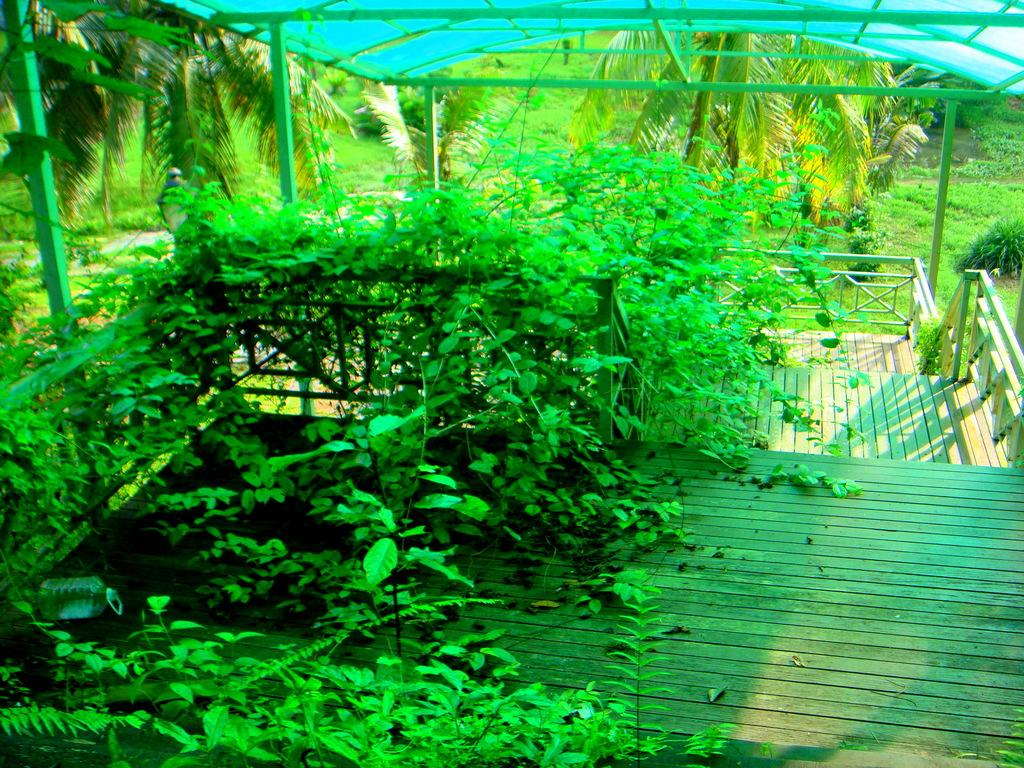What is on the fence in the image? There are plants on the fence. What is on the wooden floor in the image? There is an object on the wooden floor. What can be seen behind the fence in the image? There are trees visible behind the fence. What is the source of light in the image? There is light visible in the image. What is at the top of the image? There is a roof at the top of the image. What is the elbow's opinion about the drain in the image? There is no elbow or drain present in the image, so it is not possible to determine their opinions. 